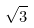Convert formula to latex. <formula><loc_0><loc_0><loc_500><loc_500>\sqrt { 3 }</formula> 